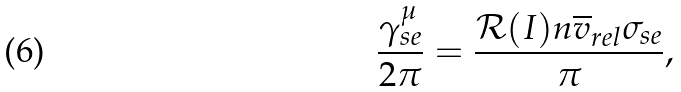<formula> <loc_0><loc_0><loc_500><loc_500>\frac { \gamma _ { s e } ^ { \mu } } { 2 \pi } = \frac { \mathcal { R } ( I ) n \overline { v } _ { r e l } \sigma _ { s e } } { \pi } ,</formula> 